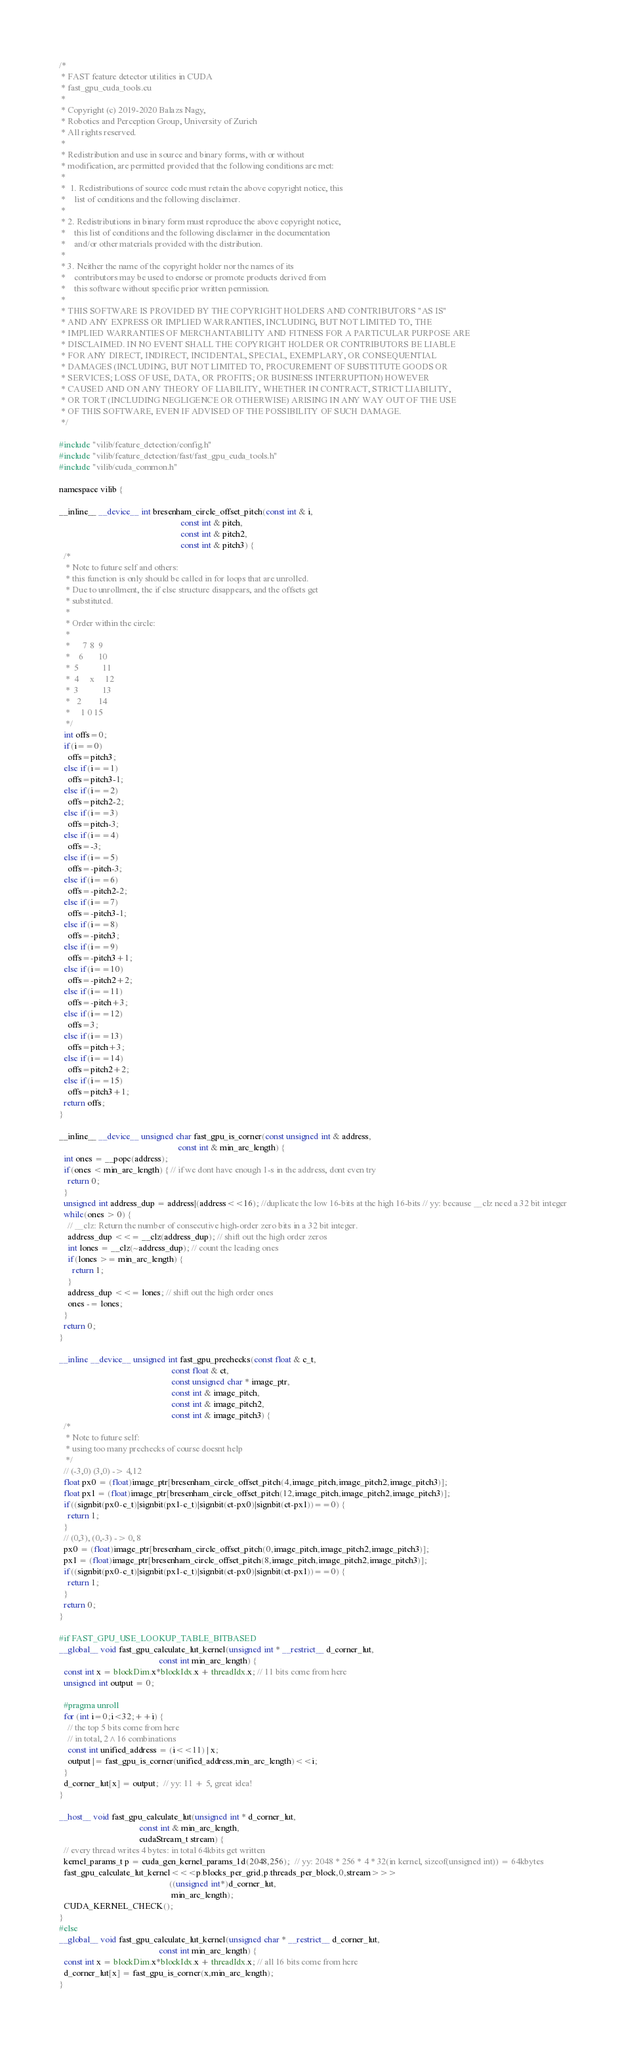Convert code to text. <code><loc_0><loc_0><loc_500><loc_500><_Cuda_>/*
 * FAST feature detector utilities in CUDA
 * fast_gpu_cuda_tools.cu
 *
 * Copyright (c) 2019-2020 Balazs Nagy,
 * Robotics and Perception Group, University of Zurich
 * All rights reserved.
 * 
 * Redistribution and use in source and binary forms, with or without
 * modification, are permitted provided that the following conditions are met:
 * 
 *  1. Redistributions of source code must retain the above copyright notice, this
 *    list of conditions and the following disclaimer.
 * 
 * 2. Redistributions in binary form must reproduce the above copyright notice,
 *    this list of conditions and the following disclaimer in the documentation
 *    and/or other materials provided with the distribution.
 * 
 * 3. Neither the name of the copyright holder nor the names of its
 *    contributors may be used to endorse or promote products derived from
 *    this software without specific prior written permission.
 * 
 * THIS SOFTWARE IS PROVIDED BY THE COPYRIGHT HOLDERS AND CONTRIBUTORS "AS IS"
 * AND ANY EXPRESS OR IMPLIED WARRANTIES, INCLUDING, BUT NOT LIMITED TO, THE
 * IMPLIED WARRANTIES OF MERCHANTABILITY AND FITNESS FOR A PARTICULAR PURPOSE ARE
 * DISCLAIMED. IN NO EVENT SHALL THE COPYRIGHT HOLDER OR CONTRIBUTORS BE LIABLE
 * FOR ANY DIRECT, INDIRECT, INCIDENTAL, SPECIAL, EXEMPLARY, OR CONSEQUENTIAL
 * DAMAGES (INCLUDING, BUT NOT LIMITED TO, PROCUREMENT OF SUBSTITUTE GOODS OR
 * SERVICES; LOSS OF USE, DATA, OR PROFITS; OR BUSINESS INTERRUPTION) HOWEVER
 * CAUSED AND ON ANY THEORY OF LIABILITY, WHETHER IN CONTRACT, STRICT LIABILITY,
 * OR TORT (INCLUDING NEGLIGENCE OR OTHERWISE) ARISING IN ANY WAY OUT OF THE USE
 * OF THIS SOFTWARE, EVEN IF ADVISED OF THE POSSIBILITY OF SUCH DAMAGE.
 */

#include "vilib/feature_detection/config.h"
#include "vilib/feature_detection/fast/fast_gpu_cuda_tools.h"
#include "vilib/cuda_common.h"

namespace vilib {

__inline__ __device__ int bresenham_circle_offset_pitch(const int & i,
                                                        const int & pitch,
                                                        const int & pitch2,
                                                        const int & pitch3) {
  /*
   * Note to future self and others:
   * this function is only should be called in for loops that are unrolled.
   * Due to unrollment, the if else structure disappears, and the offsets get
   * substituted.
   *
   * Order within the circle:
   *
   *      7 8  9
   *    6       10
   *  5           11
   *  4     x     12
   *  3           13
   *   2        14
   *     1 0 15
   */
  int offs=0;
  if(i==0)
    offs=pitch3;
  else if(i==1)
    offs=pitch3-1;
  else if(i==2)
    offs=pitch2-2;
  else if(i==3)
    offs=pitch-3;
  else if(i==4)
    offs=-3;
  else if(i==5)
    offs=-pitch-3;
  else if(i==6)
    offs=-pitch2-2;
  else if(i==7)
    offs=-pitch3-1;
  else if(i==8)
    offs=-pitch3;
  else if(i==9)
    offs=-pitch3+1;
  else if(i==10)
    offs=-pitch2+2;
  else if(i==11)
    offs=-pitch+3;
  else if(i==12)
    offs=3;
  else if(i==13)
    offs=pitch+3;
  else if(i==14)
    offs=pitch2+2;
  else if(i==15)
    offs=pitch3+1;
  return offs;
}

__inline__ __device__ unsigned char fast_gpu_is_corner(const unsigned int & address,
                                                       const int & min_arc_length) {
  int ones = __popc(address);
  if(ones < min_arc_length) { // if we dont have enough 1-s in the address, dont even try
    return 0;
  }
  unsigned int address_dup = address|(address<<16); //duplicate the low 16-bits at the high 16-bits // yy: because __clz need a 32 bit integer
  while(ones > 0) {
    // __clz: Return the number of consecutive high-order zero bits in a 32 bit integer.
    address_dup <<= __clz(address_dup); // shift out the high order zeros
    int lones = __clz(~address_dup); // count the leading ones
    if(lones >= min_arc_length) {
      return 1;
    }
    address_dup <<= lones; // shift out the high order ones
    ones -= lones;
  }
  return 0;
}

__inline __device__ unsigned int fast_gpu_prechecks(const float & c_t,
                                                    const float & ct,
                                                    const unsigned char * image_ptr,
                                                    const int & image_pitch,
                                                    const int & image_pitch2,
                                                    const int & image_pitch3) {
  /*
   * Note to future self:
   * using too many prechecks of course doesnt help
   */
  // (-3,0) (3,0) -> 4,12
  float px0 = (float)image_ptr[bresenham_circle_offset_pitch(4,image_pitch,image_pitch2,image_pitch3)];
  float px1 = (float)image_ptr[bresenham_circle_offset_pitch(12,image_pitch,image_pitch2,image_pitch3)];
  if((signbit(px0-c_t)|signbit(px1-c_t)|signbit(ct-px0)|signbit(ct-px1))==0) {
    return 1;
  }
  // (0,3), (0,-3) -> 0, 8
  px0 = (float)image_ptr[bresenham_circle_offset_pitch(0,image_pitch,image_pitch2,image_pitch3)];
  px1 = (float)image_ptr[bresenham_circle_offset_pitch(8,image_pitch,image_pitch2,image_pitch3)];
  if((signbit(px0-c_t)|signbit(px1-c_t)|signbit(ct-px0)|signbit(ct-px1))==0) {
    return 1;
  }
  return 0;
}

#if FAST_GPU_USE_LOOKUP_TABLE_BITBASED
__global__ void fast_gpu_calculate_lut_kernel(unsigned int * __restrict__ d_corner_lut,
                                              const int min_arc_length) {
  const int x = blockDim.x*blockIdx.x + threadIdx.x; // 11 bits come from here
  unsigned int output = 0;

  #pragma unroll
  for (int i=0;i<32;++i) {
    // the top 5 bits come from here
    // in total, 2^16 combinations
    const int unified_address = (i<<11) | x;
    output |= fast_gpu_is_corner(unified_address,min_arc_length)<<i;
  }
  d_corner_lut[x] = output;  // yy: 11 + 5, great idea!
}

__host__ void fast_gpu_calculate_lut(unsigned int * d_corner_lut,
                                     const int & min_arc_length,
                                     cudaStream_t stream) {
  // every thread writes 4 bytes: in total 64kbits get written
  kernel_params_t p = cuda_gen_kernel_params_1d(2048,256);  // yy: 2048 * 256 * 4 * 32(in kernel, sizeof(unsigned int)) = 64kbytes
  fast_gpu_calculate_lut_kernel<<<p.blocks_per_grid,p.threads_per_block,0,stream>>>
                                                   ((unsigned int*)d_corner_lut,
                                                    min_arc_length);
  CUDA_KERNEL_CHECK();
}
#else
__global__ void fast_gpu_calculate_lut_kernel(unsigned char * __restrict__ d_corner_lut,
                                              const int min_arc_length) {
  const int x = blockDim.x*blockIdx.x + threadIdx.x; // all 16 bits come from here
  d_corner_lut[x] = fast_gpu_is_corner(x,min_arc_length);
}
</code> 